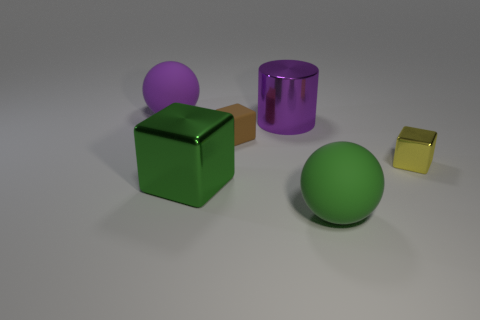Subtract all metallic blocks. How many blocks are left? 1 Subtract all purple balls. How many balls are left? 1 Subtract all cylinders. How many objects are left? 5 Subtract 1 blocks. How many blocks are left? 2 Add 3 tiny brown rubber blocks. How many objects exist? 9 Subtract 0 cyan balls. How many objects are left? 6 Subtract all purple cubes. Subtract all green cylinders. How many cubes are left? 3 Subtract all purple spheres. How many green blocks are left? 1 Subtract all brown blocks. Subtract all tiny green matte cubes. How many objects are left? 5 Add 1 yellow cubes. How many yellow cubes are left? 2 